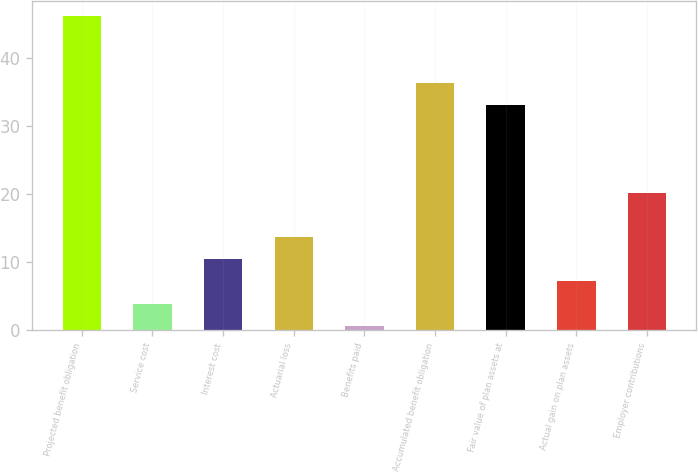Convert chart. <chart><loc_0><loc_0><loc_500><loc_500><bar_chart><fcel>Projected benefit obligation<fcel>Service cost<fcel>Interest cost<fcel>Actuarial loss<fcel>Benefits paid<fcel>Accumulated benefit obligation<fcel>Fair value of plan assets at<fcel>Actual gain on plan assets<fcel>Employer contributions<nl><fcel>46.06<fcel>3.94<fcel>10.42<fcel>13.66<fcel>0.7<fcel>36.34<fcel>33.1<fcel>7.18<fcel>20.14<nl></chart> 